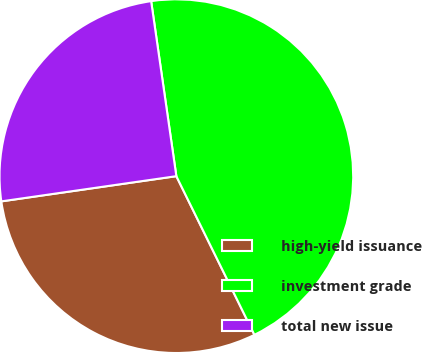<chart> <loc_0><loc_0><loc_500><loc_500><pie_chart><fcel>high-yield issuance<fcel>investment grade<fcel>total new issue<nl><fcel>30.0%<fcel>45.0%<fcel>25.0%<nl></chart> 